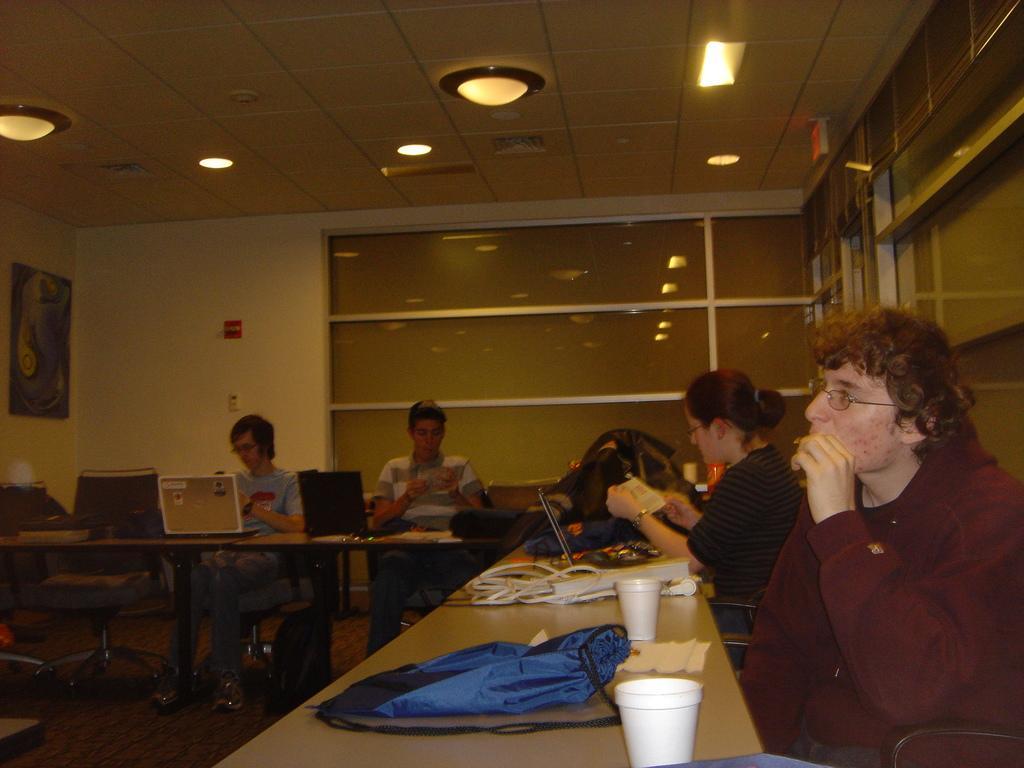Please provide a concise description of this image. In this image I can see few people are sitting on chairs. On these tables I can see laptops, glasses and a bag. 